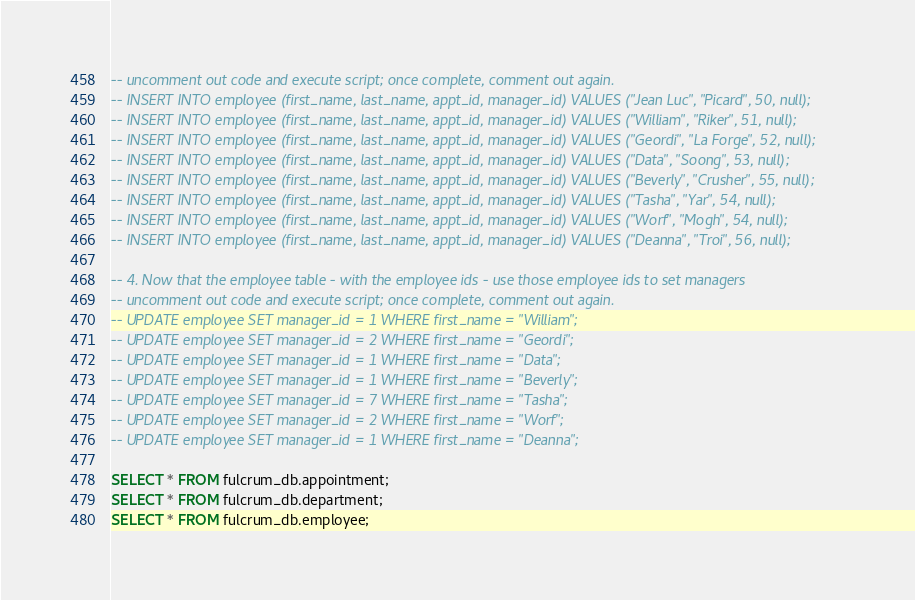<code> <loc_0><loc_0><loc_500><loc_500><_SQL_>-- uncomment out code and execute script; once complete, comment out again.
-- INSERT INTO employee (first_name, last_name, appt_id, manager_id) VALUES ("Jean Luc", "Picard", 50, null);
-- INSERT INTO employee (first_name, last_name, appt_id, manager_id) VALUES ("William", "Riker", 51, null);
-- INSERT INTO employee (first_name, last_name, appt_id, manager_id) VALUES ("Geordi", "La Forge", 52, null);
-- INSERT INTO employee (first_name, last_name, appt_id, manager_id) VALUES ("Data", "Soong", 53, null);
-- INSERT INTO employee (first_name, last_name, appt_id, manager_id) VALUES ("Beverly", "Crusher", 55, null);
-- INSERT INTO employee (first_name, last_name, appt_id, manager_id) VALUES ("Tasha", "Yar", 54, null);
-- INSERT INTO employee (first_name, last_name, appt_id, manager_id) VALUES ("Worf", "Mogh", 54, null);
-- INSERT INTO employee (first_name, last_name, appt_id, manager_id) VALUES ("Deanna", "Troi", 56, null);

-- 4. Now that the employee table - with the employee ids - use those employee ids to set managers
-- uncomment out code and execute script; once complete, comment out again.
-- UPDATE employee SET manager_id = 1 WHERE first_name = "William";
-- UPDATE employee SET manager_id = 2 WHERE first_name = "Geordi";
-- UPDATE employee SET manager_id = 1 WHERE first_name = "Data";
-- UPDATE employee SET manager_id = 1 WHERE first_name = "Beverly";
-- UPDATE employee SET manager_id = 7 WHERE first_name = "Tasha";
-- UPDATE employee SET manager_id = 2 WHERE first_name = "Worf";
-- UPDATE employee SET manager_id = 1 WHERE first_name = "Deanna";

SELECT * FROM fulcrum_db.appointment;
SELECT * FROM fulcrum_db.department;
SELECT * FROM fulcrum_db.employee;
</code> 